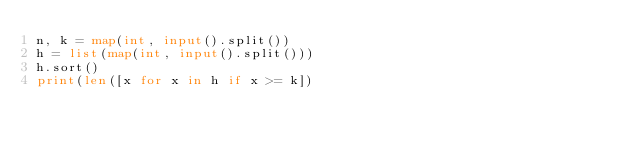Convert code to text. <code><loc_0><loc_0><loc_500><loc_500><_Python_>n, k = map(int, input().split())
h = list(map(int, input().split()))
h.sort()
print(len([x for x in h if x >= k])</code> 